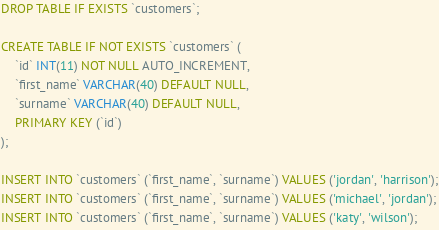<code> <loc_0><loc_0><loc_500><loc_500><_SQL_>DROP TABLE IF EXISTS `customers`;

CREATE TABLE IF NOT EXISTS `customers` (
    `id` INT(11) NOT NULL AUTO_INCREMENT,
    `first_name` VARCHAR(40) DEFAULT NULL,
    `surname` VARCHAR(40) DEFAULT NULL,
    PRIMARY KEY (`id`)
);

INSERT INTO `customers` (`first_name`, `surname`) VALUES ('jordan', 'harrison');
INSERT INTO `customers` (`first_name`, `surname`) VALUES ('michael', 'jordan');
INSERT INTO `customers` (`first_name`, `surname`) VALUES ('katy', 'wilson');</code> 